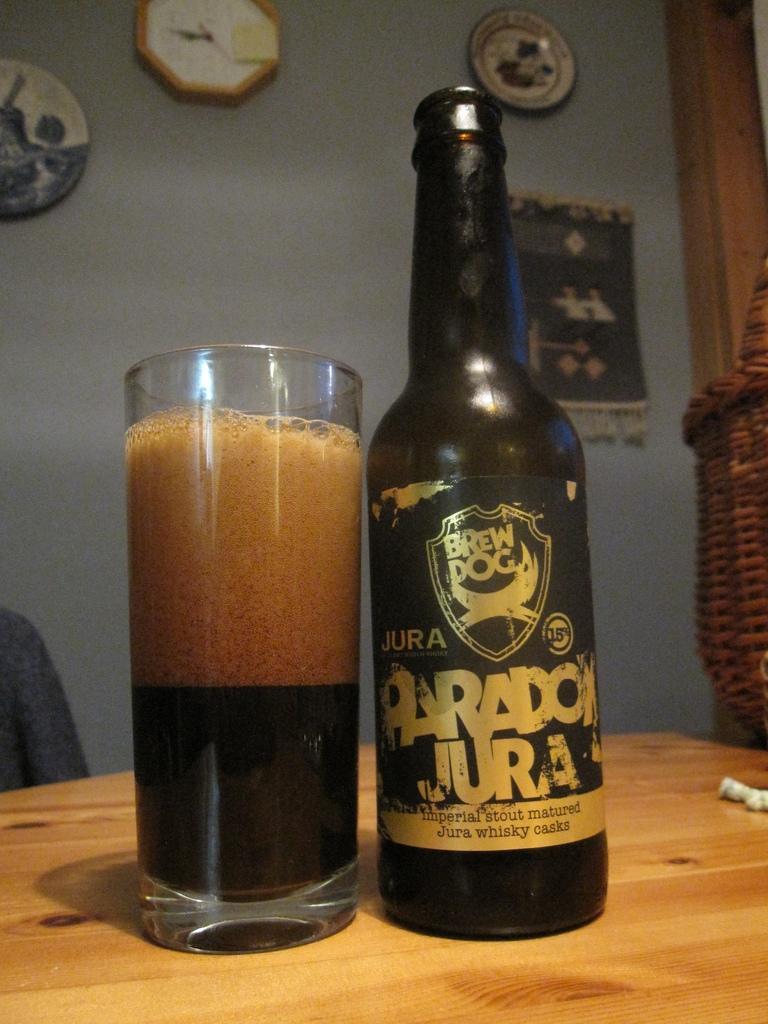What type of cask was the beer fermented in?
Your response must be concise. Whisky. Jura pardon beer?
Your response must be concise. Yes. 